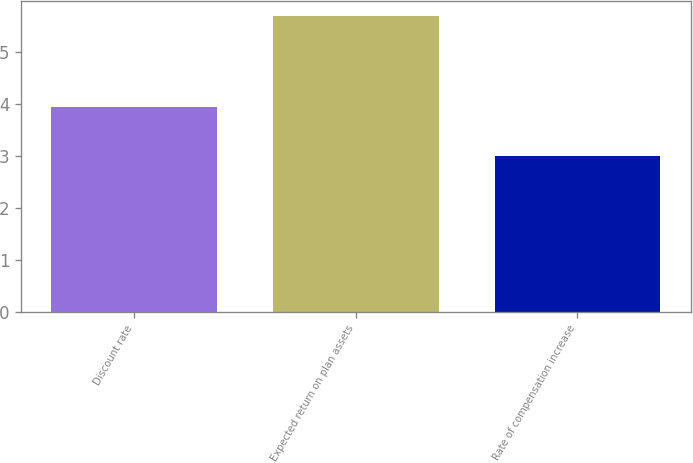Convert chart to OTSL. <chart><loc_0><loc_0><loc_500><loc_500><bar_chart><fcel>Discount rate<fcel>Expected return on plan assets<fcel>Rate of compensation increase<nl><fcel>3.95<fcel>5.7<fcel>3<nl></chart> 